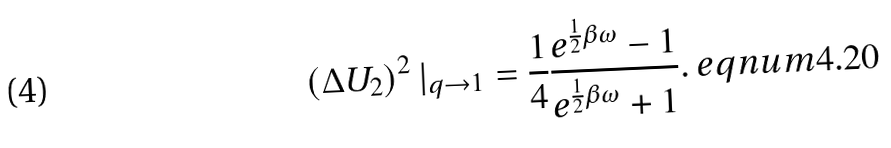<formula> <loc_0><loc_0><loc_500><loc_500>\left ( \Delta U _ { 2 } \right ) ^ { 2 } | _ { q \rightarrow 1 } = \frac { 1 } { 4 } \frac { e ^ { \frac { 1 } { 2 } \beta \omega } - 1 } { e ^ { \frac { 1 } { 2 } \beta \omega } + 1 } . \ e q n u m { 4 . 2 0 }</formula> 